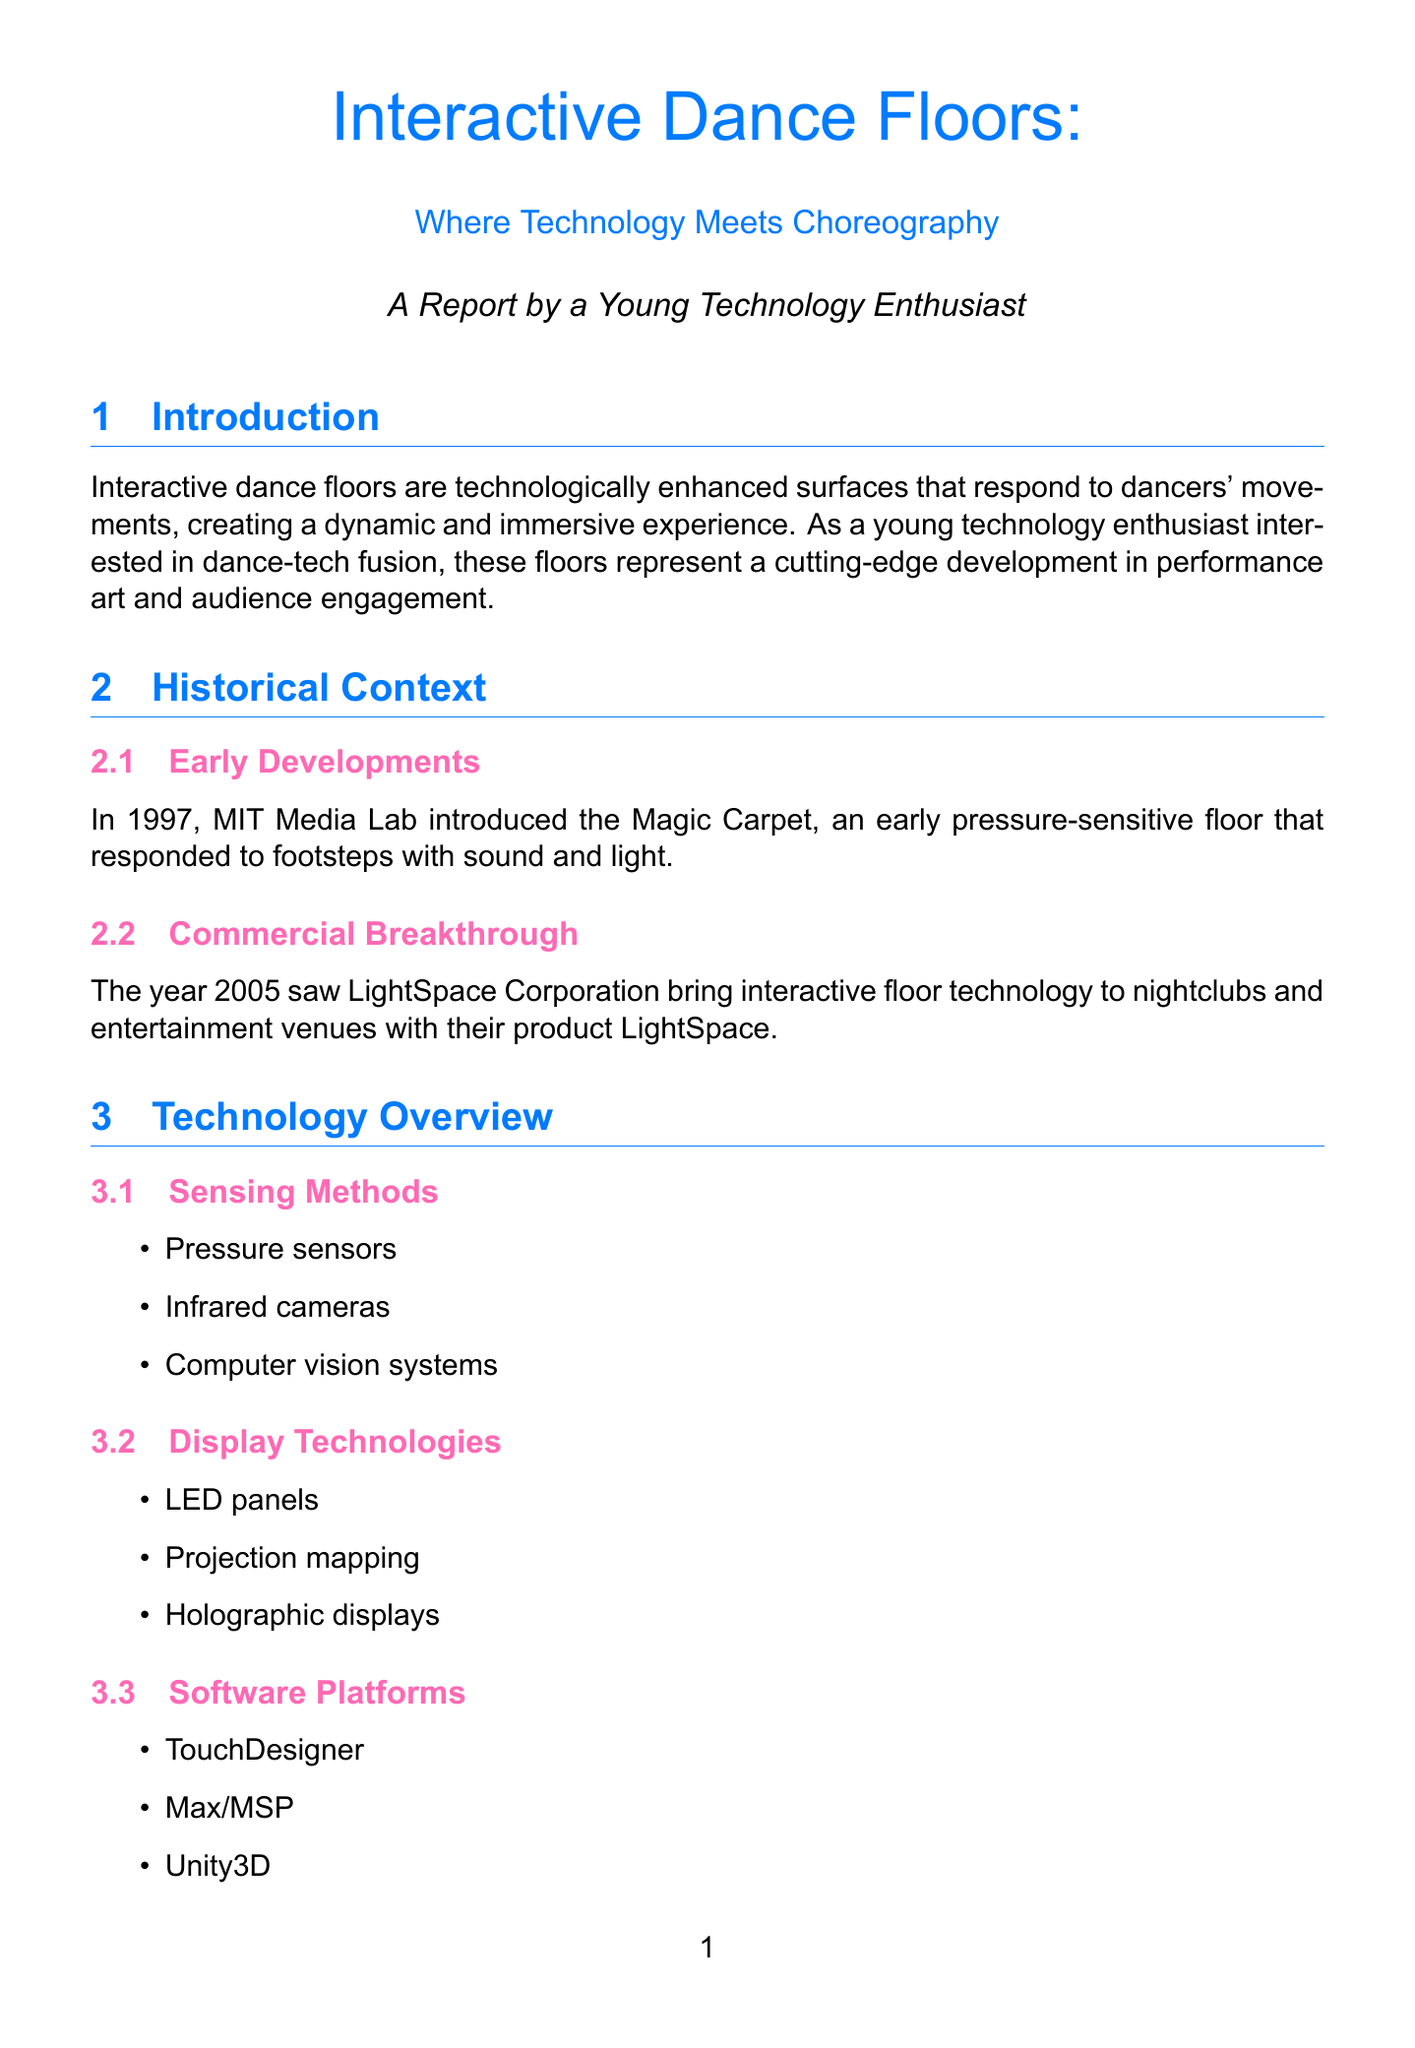What are interactive dance floors? Interactive dance floors are defined in the document as technologically enhanced surfaces that respond to dancers' movements, creating a dynamic and immersive experience.
Answer: Technologically enhanced surfaces that respond to dancers' movements What year was the Magic Carpet introduced? The document states that the Magic Carpet was introduced in 1997.
Answer: 1997 What technology brought interactive floors to nightclubs in 2005? The product mentioned in the document that brought interactive floors to nightclubs is LightSpace.
Answer: LightSpace Name a software platform used for interactive dance floors. The document lists various software platforms, one of which is TouchDesigner.
Answer: TouchDesigner What is a notable performance that integrates dancers with digital projections? The document mentions "Pixel" as a groundbreaking performance that integrates dancers with interactive digital projections.
Answer: Pixel What challenges do dancers face with interactive dance floors? The document highlights balancing technology with traditional dance techniques as one of the challenges faced by dancers.
Answer: Balancing technology with traditional dance techniques What is an example of an interactive installation mentioned? GestureTek's GroundFX is cited in the document as an example of an interactive installation.
Answer: GestureTek's GroundFX What future trend involves audience participation through blockchain? The document states that one future trend is blockchain-based interactive performances for decentralized audience participation.
Answer: Blockchain-based interactive performances What project aims to integrate software with interactive floors for education? DanceForms by Credo Interactive is the project mentioned in the document that integrates software with interactive floors for dance education.
Answer: DanceForms by Credo Interactive 